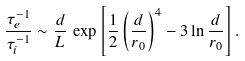<formula> <loc_0><loc_0><loc_500><loc_500>\frac { \tau _ { e } ^ { - 1 } } { \tau _ { i } ^ { - 1 } } \sim \frac { d } { L } \, \exp \left [ \frac { 1 } { 2 } \left ( \frac { d } { r _ { 0 } } \right ) ^ { 4 } - 3 \ln \frac { d } { r _ { 0 } } \right ] .</formula> 